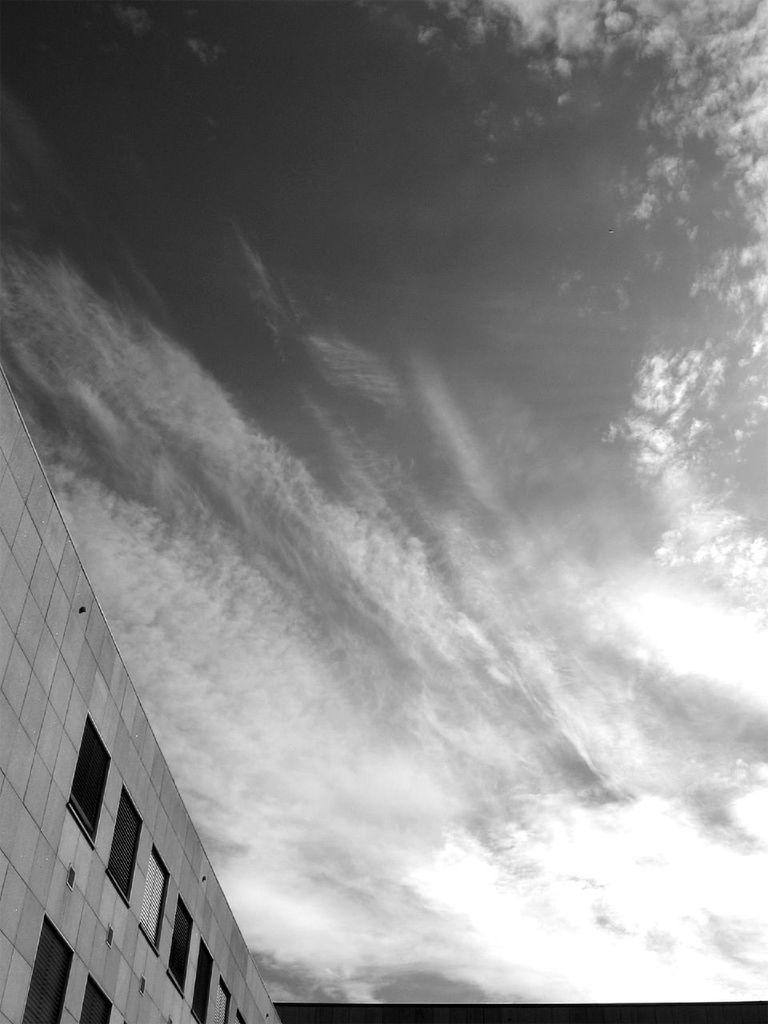What is the color scheme of the image? The image is black and white. What structure can be seen in the left bottom of the image? There is a building in the left bottom of the image. What feature can be observed on the building? The building has glass windows. What can be seen in the background of the image? There are clouds and the sky visible in the background of the image. What type of sign can be seen on the building in the image? There is no sign visible on the building in the image. Can you tell me how many volleyballs are present in the image? There are no volleyballs present in the image. 